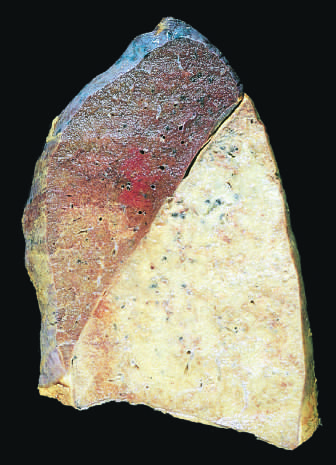s the left ventricle uniformly consolidated?
Answer the question using a single word or phrase. No 